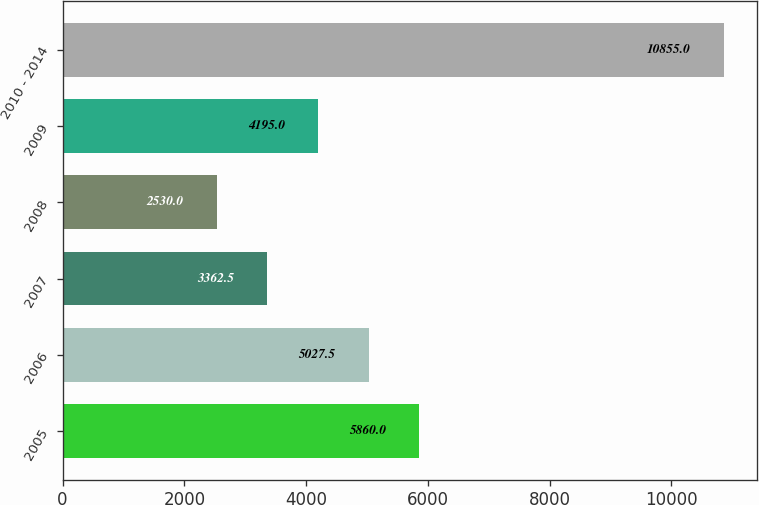Convert chart to OTSL. <chart><loc_0><loc_0><loc_500><loc_500><bar_chart><fcel>2005<fcel>2006<fcel>2007<fcel>2008<fcel>2009<fcel>2010 - 2014<nl><fcel>5860<fcel>5027.5<fcel>3362.5<fcel>2530<fcel>4195<fcel>10855<nl></chart> 